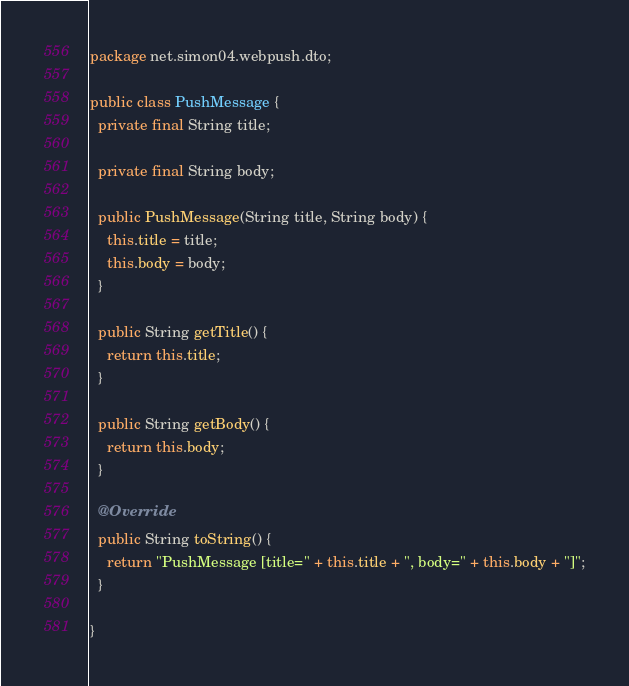Convert code to text. <code><loc_0><loc_0><loc_500><loc_500><_Java_>package net.simon04.webpush.dto;

public class PushMessage {
  private final String title;

  private final String body;

  public PushMessage(String title, String body) {
    this.title = title;
    this.body = body;
  }

  public String getTitle() {
    return this.title;
  }

  public String getBody() {
    return this.body;
  }

  @Override
  public String toString() {
    return "PushMessage [title=" + this.title + ", body=" + this.body + "]";
  }

}
</code> 